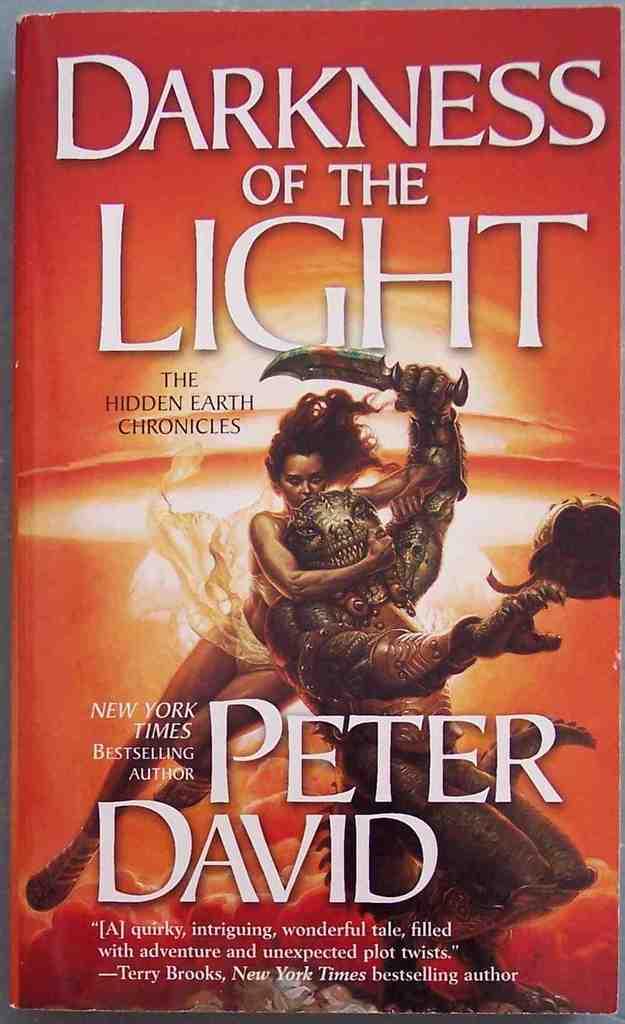Who is the author of this book?
Make the answer very short. Peter david. Darkness of the what?
Provide a succinct answer. Light. 